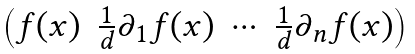<formula> <loc_0><loc_0><loc_500><loc_500>\begin{pmatrix} f ( x ) & \frac { 1 } { d } \partial _ { 1 } f ( x ) & \cdots & \frac { 1 } { d } \partial _ { n } f ( x ) \end{pmatrix}</formula> 